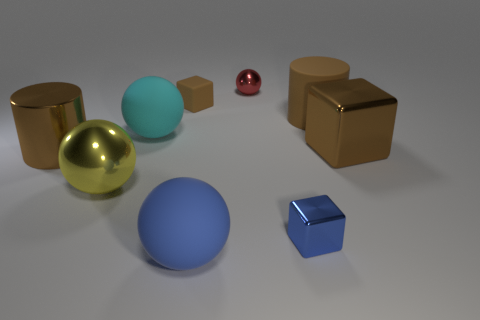Subtract all red balls. How many balls are left? 3 Subtract all gray spheres. Subtract all brown cylinders. How many spheres are left? 4 Subtract all cylinders. How many objects are left? 7 Add 1 large matte things. How many objects exist? 10 Add 9 big yellow metallic things. How many big yellow metallic things exist? 10 Subtract 0 yellow cylinders. How many objects are left? 9 Subtract all large brown shiny objects. Subtract all large blocks. How many objects are left? 6 Add 1 small cubes. How many small cubes are left? 3 